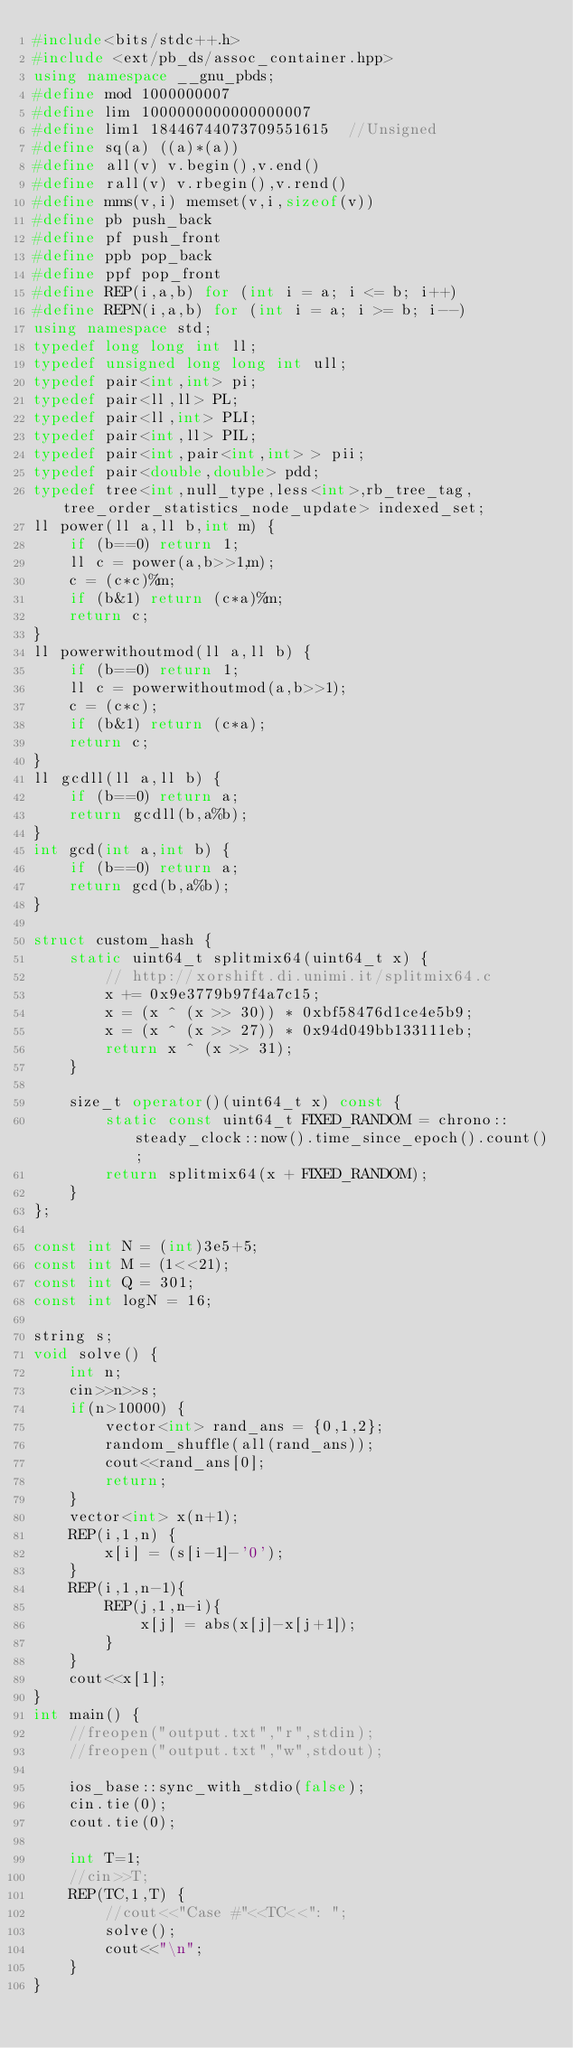<code> <loc_0><loc_0><loc_500><loc_500><_C++_>#include<bits/stdc++.h>
#include <ext/pb_ds/assoc_container.hpp>
using namespace __gnu_pbds;
#define mod 1000000007
#define lim 1000000000000000007
#define lim1 18446744073709551615  //Unsigned
#define sq(a) ((a)*(a))
#define all(v) v.begin(),v.end()
#define rall(v) v.rbegin(),v.rend()
#define mms(v,i) memset(v,i,sizeof(v))
#define pb push_back
#define pf push_front
#define ppb pop_back
#define ppf pop_front
#define REP(i,a,b) for (int i = a; i <= b; i++)
#define REPN(i,a,b) for (int i = a; i >= b; i--)
using namespace std;
typedef long long int ll;
typedef unsigned long long int ull;
typedef pair<int,int> pi;
typedef pair<ll,ll> PL;
typedef pair<ll,int> PLI;
typedef pair<int,ll> PIL;
typedef pair<int,pair<int,int> > pii;
typedef pair<double,double> pdd;
typedef tree<int,null_type,less<int>,rb_tree_tag,tree_order_statistics_node_update> indexed_set;
ll power(ll a,ll b,int m) {
    if (b==0) return 1;
    ll c = power(a,b>>1,m);
    c = (c*c)%m;
    if (b&1) return (c*a)%m;
    return c;
}
ll powerwithoutmod(ll a,ll b) {
    if (b==0) return 1;
    ll c = powerwithoutmod(a,b>>1);
    c = (c*c);
    if (b&1) return (c*a);
    return c;
}
ll gcdll(ll a,ll b) {
    if (b==0) return a;
    return gcdll(b,a%b);
}
int gcd(int a,int b) {
    if (b==0) return a;
    return gcd(b,a%b);
}

struct custom_hash {
    static uint64_t splitmix64(uint64_t x) {
        // http://xorshift.di.unimi.it/splitmix64.c
        x += 0x9e3779b97f4a7c15;
        x = (x ^ (x >> 30)) * 0xbf58476d1ce4e5b9;
        x = (x ^ (x >> 27)) * 0x94d049bb133111eb;
        return x ^ (x >> 31);
    }

    size_t operator()(uint64_t x) const {
        static const uint64_t FIXED_RANDOM = chrono::steady_clock::now().time_since_epoch().count();
        return splitmix64(x + FIXED_RANDOM);
    }
};

const int N = (int)3e5+5;
const int M = (1<<21);
const int Q = 301;
const int logN = 16;

string s;
void solve() {
    int n;
    cin>>n>>s;
    if(n>10000) {
        vector<int> rand_ans = {0,1,2};
        random_shuffle(all(rand_ans));
        cout<<rand_ans[0];
        return;
    }
    vector<int> x(n+1);
    REP(i,1,n) {
        x[i] = (s[i-1]-'0');
    }
    REP(i,1,n-1){
        REP(j,1,n-i){
            x[j] = abs(x[j]-x[j+1]);
        }
    }
    cout<<x[1];
}
int main() {
    //freopen("output.txt","r",stdin);
    //freopen("output.txt","w",stdout);

    ios_base::sync_with_stdio(false);
    cin.tie(0);
    cout.tie(0);

    int T=1;
    //cin>>T;
    REP(TC,1,T) {
        //cout<<"Case #"<<TC<<": ";
        solve();
        cout<<"\n";
    }
}
</code> 